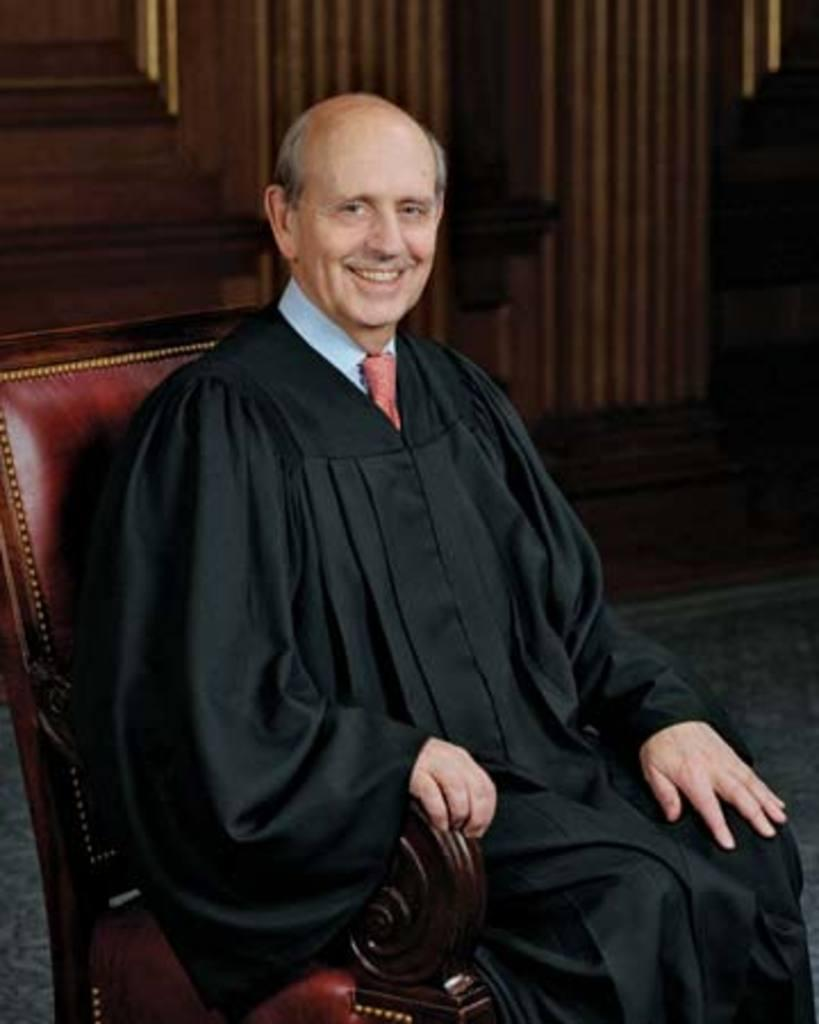What is the man in the image doing? The man is sitting on a chair in the image. What is the surface beneath the man's feet? There is a floor visible in the image. What can be seen behind the man in the image? There is a wall in the background of the image. What type of oil is being used by the man in the image? There is no oil present in the image; the man is simply sitting on a chair. What color is the sock on the man's foot in the image? The man's feet are not visible in the image, so we cannot determine the color of any socks he might be wearing. 